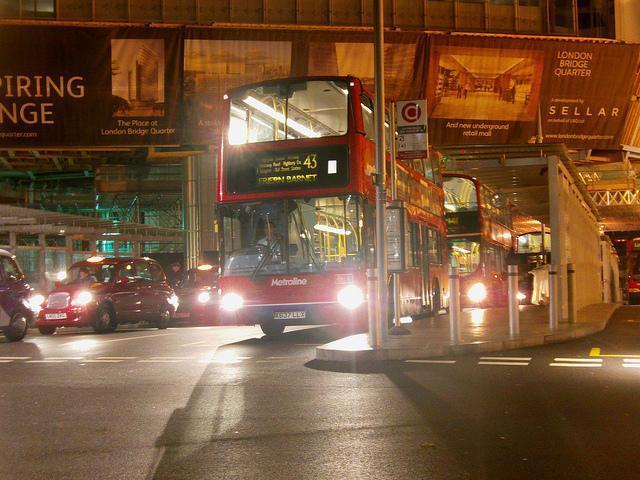How many cars are in the picture?
Give a very brief answer. 3. How many buses can you see?
Give a very brief answer. 2. 